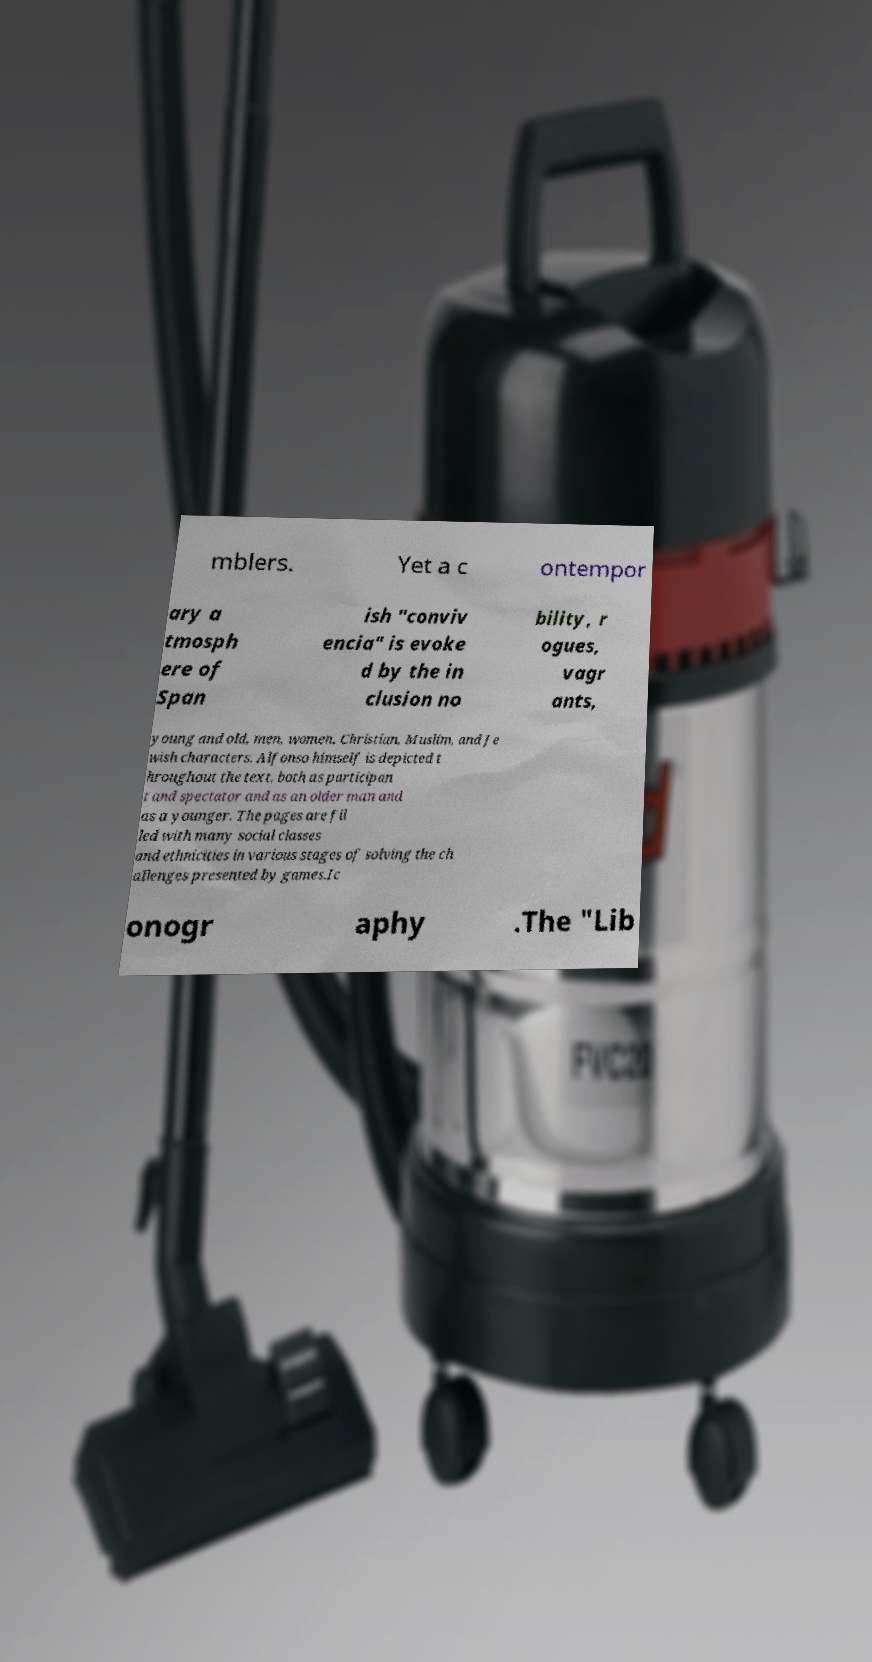Could you assist in decoding the text presented in this image and type it out clearly? mblers. Yet a c ontempor ary a tmosph ere of Span ish "conviv encia" is evoke d by the in clusion no bility, r ogues, vagr ants, young and old, men, women, Christian, Muslim, and Je wish characters. Alfonso himself is depicted t hroughout the text, both as participan t and spectator and as an older man and as a younger. The pages are fil led with many social classes and ethnicities in various stages of solving the ch allenges presented by games.Ic onogr aphy .The "Lib 